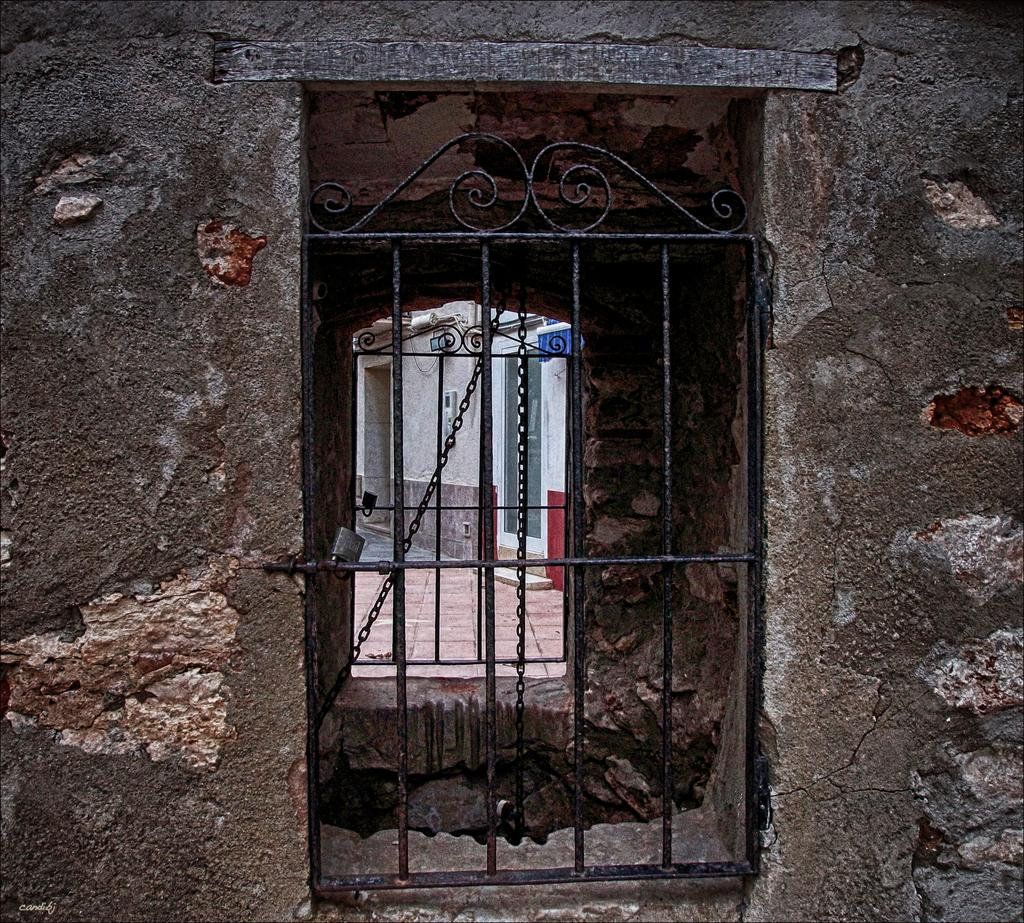What type of structure is in the image? There is a house in the image. What part of the house is visible in the image? There is a window in the house. Is there any entrance to the house visible in the image? Yes, there is a gate associated with the house. What can be seen through the window in the image? There is a building visible through the window. What is on the wall inside the house? There is a board on the wall. How many apples are on the mother's connection in the image? There are no apples, mother, or connection present in the image. 